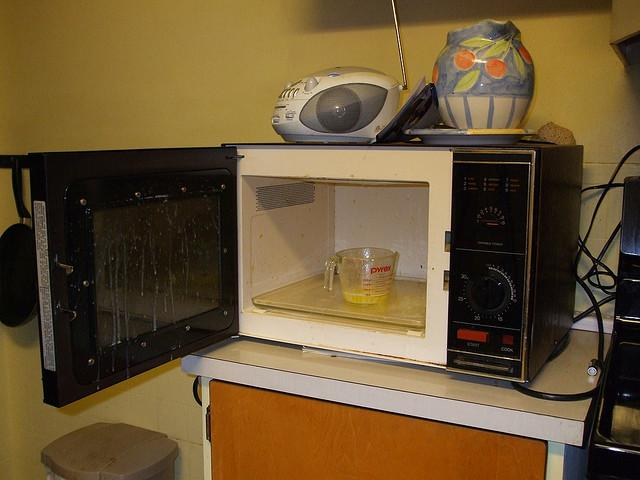How is the measuring cup being heated? microwave 